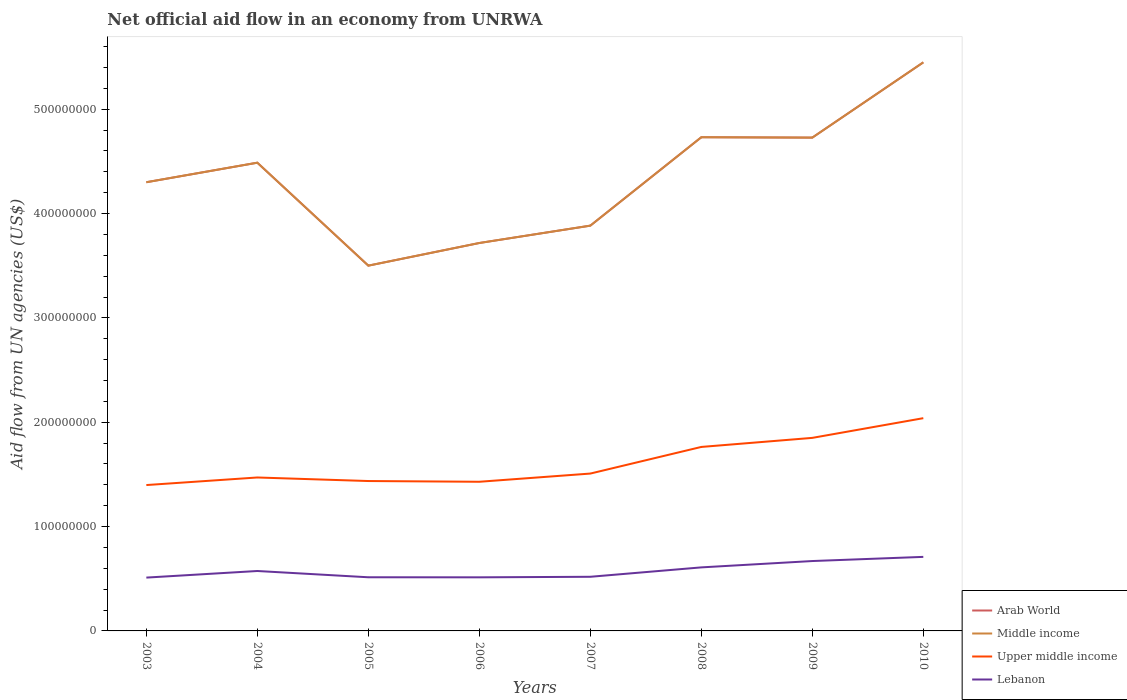How many different coloured lines are there?
Offer a very short reply. 4. Is the number of lines equal to the number of legend labels?
Keep it short and to the point. Yes. Across all years, what is the maximum net official aid flow in Arab World?
Offer a terse response. 3.50e+08. What is the total net official aid flow in Upper middle income in the graph?
Your answer should be very brief. -6.41e+07. What is the difference between the highest and the second highest net official aid flow in Lebanon?
Ensure brevity in your answer.  1.99e+07. What is the difference between the highest and the lowest net official aid flow in Upper middle income?
Offer a terse response. 3. Is the net official aid flow in Lebanon strictly greater than the net official aid flow in Upper middle income over the years?
Ensure brevity in your answer.  Yes. How many lines are there?
Ensure brevity in your answer.  4. How many years are there in the graph?
Offer a terse response. 8. What is the difference between two consecutive major ticks on the Y-axis?
Make the answer very short. 1.00e+08. Are the values on the major ticks of Y-axis written in scientific E-notation?
Your response must be concise. No. How many legend labels are there?
Provide a short and direct response. 4. How are the legend labels stacked?
Your answer should be very brief. Vertical. What is the title of the graph?
Offer a terse response. Net official aid flow in an economy from UNRWA. Does "Sao Tome and Principe" appear as one of the legend labels in the graph?
Your answer should be very brief. No. What is the label or title of the X-axis?
Your answer should be very brief. Years. What is the label or title of the Y-axis?
Ensure brevity in your answer.  Aid flow from UN agencies (US$). What is the Aid flow from UN agencies (US$) in Arab World in 2003?
Keep it short and to the point. 4.30e+08. What is the Aid flow from UN agencies (US$) in Middle income in 2003?
Provide a succinct answer. 4.30e+08. What is the Aid flow from UN agencies (US$) of Upper middle income in 2003?
Keep it short and to the point. 1.40e+08. What is the Aid flow from UN agencies (US$) of Lebanon in 2003?
Give a very brief answer. 5.11e+07. What is the Aid flow from UN agencies (US$) in Arab World in 2004?
Provide a succinct answer. 4.49e+08. What is the Aid flow from UN agencies (US$) of Middle income in 2004?
Offer a very short reply. 4.49e+08. What is the Aid flow from UN agencies (US$) of Upper middle income in 2004?
Your answer should be very brief. 1.47e+08. What is the Aid flow from UN agencies (US$) in Lebanon in 2004?
Offer a very short reply. 5.74e+07. What is the Aid flow from UN agencies (US$) in Arab World in 2005?
Provide a succinct answer. 3.50e+08. What is the Aid flow from UN agencies (US$) of Middle income in 2005?
Provide a short and direct response. 3.50e+08. What is the Aid flow from UN agencies (US$) of Upper middle income in 2005?
Provide a short and direct response. 1.44e+08. What is the Aid flow from UN agencies (US$) in Lebanon in 2005?
Provide a succinct answer. 5.14e+07. What is the Aid flow from UN agencies (US$) in Arab World in 2006?
Offer a very short reply. 3.72e+08. What is the Aid flow from UN agencies (US$) in Middle income in 2006?
Ensure brevity in your answer.  3.72e+08. What is the Aid flow from UN agencies (US$) in Upper middle income in 2006?
Provide a short and direct response. 1.43e+08. What is the Aid flow from UN agencies (US$) in Lebanon in 2006?
Give a very brief answer. 5.14e+07. What is the Aid flow from UN agencies (US$) in Arab World in 2007?
Offer a terse response. 3.88e+08. What is the Aid flow from UN agencies (US$) in Middle income in 2007?
Give a very brief answer. 3.88e+08. What is the Aid flow from UN agencies (US$) in Upper middle income in 2007?
Ensure brevity in your answer.  1.51e+08. What is the Aid flow from UN agencies (US$) in Lebanon in 2007?
Offer a terse response. 5.19e+07. What is the Aid flow from UN agencies (US$) of Arab World in 2008?
Give a very brief answer. 4.73e+08. What is the Aid flow from UN agencies (US$) in Middle income in 2008?
Provide a short and direct response. 4.73e+08. What is the Aid flow from UN agencies (US$) in Upper middle income in 2008?
Provide a short and direct response. 1.76e+08. What is the Aid flow from UN agencies (US$) of Lebanon in 2008?
Ensure brevity in your answer.  6.09e+07. What is the Aid flow from UN agencies (US$) of Arab World in 2009?
Provide a succinct answer. 4.73e+08. What is the Aid flow from UN agencies (US$) in Middle income in 2009?
Offer a very short reply. 4.73e+08. What is the Aid flow from UN agencies (US$) in Upper middle income in 2009?
Provide a short and direct response. 1.85e+08. What is the Aid flow from UN agencies (US$) of Lebanon in 2009?
Offer a terse response. 6.70e+07. What is the Aid flow from UN agencies (US$) in Arab World in 2010?
Offer a terse response. 5.45e+08. What is the Aid flow from UN agencies (US$) in Middle income in 2010?
Keep it short and to the point. 5.45e+08. What is the Aid flow from UN agencies (US$) in Upper middle income in 2010?
Offer a terse response. 2.04e+08. What is the Aid flow from UN agencies (US$) in Lebanon in 2010?
Give a very brief answer. 7.10e+07. Across all years, what is the maximum Aid flow from UN agencies (US$) of Arab World?
Ensure brevity in your answer.  5.45e+08. Across all years, what is the maximum Aid flow from UN agencies (US$) of Middle income?
Offer a very short reply. 5.45e+08. Across all years, what is the maximum Aid flow from UN agencies (US$) of Upper middle income?
Make the answer very short. 2.04e+08. Across all years, what is the maximum Aid flow from UN agencies (US$) of Lebanon?
Give a very brief answer. 7.10e+07. Across all years, what is the minimum Aid flow from UN agencies (US$) in Arab World?
Your answer should be compact. 3.50e+08. Across all years, what is the minimum Aid flow from UN agencies (US$) of Middle income?
Offer a terse response. 3.50e+08. Across all years, what is the minimum Aid flow from UN agencies (US$) of Upper middle income?
Provide a short and direct response. 1.40e+08. Across all years, what is the minimum Aid flow from UN agencies (US$) in Lebanon?
Give a very brief answer. 5.11e+07. What is the total Aid flow from UN agencies (US$) of Arab World in the graph?
Offer a very short reply. 3.48e+09. What is the total Aid flow from UN agencies (US$) in Middle income in the graph?
Offer a terse response. 3.48e+09. What is the total Aid flow from UN agencies (US$) in Upper middle income in the graph?
Your answer should be compact. 1.29e+09. What is the total Aid flow from UN agencies (US$) in Lebanon in the graph?
Your answer should be very brief. 4.62e+08. What is the difference between the Aid flow from UN agencies (US$) in Arab World in 2003 and that in 2004?
Make the answer very short. -1.87e+07. What is the difference between the Aid flow from UN agencies (US$) of Middle income in 2003 and that in 2004?
Offer a terse response. -1.87e+07. What is the difference between the Aid flow from UN agencies (US$) of Upper middle income in 2003 and that in 2004?
Keep it short and to the point. -7.26e+06. What is the difference between the Aid flow from UN agencies (US$) of Lebanon in 2003 and that in 2004?
Make the answer very short. -6.32e+06. What is the difference between the Aid flow from UN agencies (US$) of Arab World in 2003 and that in 2005?
Make the answer very short. 8.00e+07. What is the difference between the Aid flow from UN agencies (US$) in Middle income in 2003 and that in 2005?
Your answer should be very brief. 8.00e+07. What is the difference between the Aid flow from UN agencies (US$) in Upper middle income in 2003 and that in 2005?
Your response must be concise. -3.86e+06. What is the difference between the Aid flow from UN agencies (US$) of Lebanon in 2003 and that in 2005?
Offer a very short reply. -3.10e+05. What is the difference between the Aid flow from UN agencies (US$) in Arab World in 2003 and that in 2006?
Offer a terse response. 5.82e+07. What is the difference between the Aid flow from UN agencies (US$) of Middle income in 2003 and that in 2006?
Provide a succinct answer. 5.82e+07. What is the difference between the Aid flow from UN agencies (US$) of Upper middle income in 2003 and that in 2006?
Your response must be concise. -3.15e+06. What is the difference between the Aid flow from UN agencies (US$) of Lebanon in 2003 and that in 2006?
Your answer should be compact. -2.50e+05. What is the difference between the Aid flow from UN agencies (US$) of Arab World in 2003 and that in 2007?
Give a very brief answer. 4.16e+07. What is the difference between the Aid flow from UN agencies (US$) in Middle income in 2003 and that in 2007?
Your answer should be very brief. 4.16e+07. What is the difference between the Aid flow from UN agencies (US$) in Upper middle income in 2003 and that in 2007?
Your answer should be very brief. -1.10e+07. What is the difference between the Aid flow from UN agencies (US$) of Lebanon in 2003 and that in 2007?
Your response must be concise. -7.80e+05. What is the difference between the Aid flow from UN agencies (US$) of Arab World in 2003 and that in 2008?
Provide a short and direct response. -4.31e+07. What is the difference between the Aid flow from UN agencies (US$) in Middle income in 2003 and that in 2008?
Provide a short and direct response. -4.31e+07. What is the difference between the Aid flow from UN agencies (US$) in Upper middle income in 2003 and that in 2008?
Keep it short and to the point. -3.65e+07. What is the difference between the Aid flow from UN agencies (US$) in Lebanon in 2003 and that in 2008?
Offer a terse response. -9.79e+06. What is the difference between the Aid flow from UN agencies (US$) of Arab World in 2003 and that in 2009?
Offer a very short reply. -4.28e+07. What is the difference between the Aid flow from UN agencies (US$) in Middle income in 2003 and that in 2009?
Provide a short and direct response. -4.28e+07. What is the difference between the Aid flow from UN agencies (US$) in Upper middle income in 2003 and that in 2009?
Offer a very short reply. -4.52e+07. What is the difference between the Aid flow from UN agencies (US$) of Lebanon in 2003 and that in 2009?
Offer a terse response. -1.59e+07. What is the difference between the Aid flow from UN agencies (US$) in Arab World in 2003 and that in 2010?
Keep it short and to the point. -1.15e+08. What is the difference between the Aid flow from UN agencies (US$) of Middle income in 2003 and that in 2010?
Ensure brevity in your answer.  -1.15e+08. What is the difference between the Aid flow from UN agencies (US$) in Upper middle income in 2003 and that in 2010?
Provide a short and direct response. -6.41e+07. What is the difference between the Aid flow from UN agencies (US$) of Lebanon in 2003 and that in 2010?
Your answer should be very brief. -1.99e+07. What is the difference between the Aid flow from UN agencies (US$) in Arab World in 2004 and that in 2005?
Your response must be concise. 9.87e+07. What is the difference between the Aid flow from UN agencies (US$) of Middle income in 2004 and that in 2005?
Your answer should be compact. 9.87e+07. What is the difference between the Aid flow from UN agencies (US$) in Upper middle income in 2004 and that in 2005?
Provide a short and direct response. 3.40e+06. What is the difference between the Aid flow from UN agencies (US$) in Lebanon in 2004 and that in 2005?
Your answer should be very brief. 6.01e+06. What is the difference between the Aid flow from UN agencies (US$) in Arab World in 2004 and that in 2006?
Keep it short and to the point. 7.70e+07. What is the difference between the Aid flow from UN agencies (US$) of Middle income in 2004 and that in 2006?
Offer a terse response. 7.70e+07. What is the difference between the Aid flow from UN agencies (US$) in Upper middle income in 2004 and that in 2006?
Make the answer very short. 4.11e+06. What is the difference between the Aid flow from UN agencies (US$) in Lebanon in 2004 and that in 2006?
Offer a terse response. 6.07e+06. What is the difference between the Aid flow from UN agencies (US$) in Arab World in 2004 and that in 2007?
Provide a succinct answer. 6.03e+07. What is the difference between the Aid flow from UN agencies (US$) in Middle income in 2004 and that in 2007?
Make the answer very short. 6.03e+07. What is the difference between the Aid flow from UN agencies (US$) of Upper middle income in 2004 and that in 2007?
Your answer should be compact. -3.75e+06. What is the difference between the Aid flow from UN agencies (US$) in Lebanon in 2004 and that in 2007?
Your response must be concise. 5.54e+06. What is the difference between the Aid flow from UN agencies (US$) in Arab World in 2004 and that in 2008?
Keep it short and to the point. -2.44e+07. What is the difference between the Aid flow from UN agencies (US$) in Middle income in 2004 and that in 2008?
Give a very brief answer. -2.44e+07. What is the difference between the Aid flow from UN agencies (US$) of Upper middle income in 2004 and that in 2008?
Offer a very short reply. -2.93e+07. What is the difference between the Aid flow from UN agencies (US$) in Lebanon in 2004 and that in 2008?
Ensure brevity in your answer.  -3.47e+06. What is the difference between the Aid flow from UN agencies (US$) of Arab World in 2004 and that in 2009?
Give a very brief answer. -2.40e+07. What is the difference between the Aid flow from UN agencies (US$) of Middle income in 2004 and that in 2009?
Offer a very short reply. -2.40e+07. What is the difference between the Aid flow from UN agencies (US$) in Upper middle income in 2004 and that in 2009?
Your answer should be compact. -3.80e+07. What is the difference between the Aid flow from UN agencies (US$) of Lebanon in 2004 and that in 2009?
Your response must be concise. -9.55e+06. What is the difference between the Aid flow from UN agencies (US$) in Arab World in 2004 and that in 2010?
Provide a succinct answer. -9.62e+07. What is the difference between the Aid flow from UN agencies (US$) in Middle income in 2004 and that in 2010?
Provide a short and direct response. -9.62e+07. What is the difference between the Aid flow from UN agencies (US$) in Upper middle income in 2004 and that in 2010?
Your response must be concise. -5.68e+07. What is the difference between the Aid flow from UN agencies (US$) in Lebanon in 2004 and that in 2010?
Provide a short and direct response. -1.35e+07. What is the difference between the Aid flow from UN agencies (US$) in Arab World in 2005 and that in 2006?
Ensure brevity in your answer.  -2.17e+07. What is the difference between the Aid flow from UN agencies (US$) in Middle income in 2005 and that in 2006?
Your answer should be compact. -2.17e+07. What is the difference between the Aid flow from UN agencies (US$) of Upper middle income in 2005 and that in 2006?
Your response must be concise. 7.10e+05. What is the difference between the Aid flow from UN agencies (US$) of Arab World in 2005 and that in 2007?
Offer a terse response. -3.83e+07. What is the difference between the Aid flow from UN agencies (US$) in Middle income in 2005 and that in 2007?
Give a very brief answer. -3.83e+07. What is the difference between the Aid flow from UN agencies (US$) of Upper middle income in 2005 and that in 2007?
Make the answer very short. -7.15e+06. What is the difference between the Aid flow from UN agencies (US$) of Lebanon in 2005 and that in 2007?
Provide a short and direct response. -4.70e+05. What is the difference between the Aid flow from UN agencies (US$) in Arab World in 2005 and that in 2008?
Offer a terse response. -1.23e+08. What is the difference between the Aid flow from UN agencies (US$) of Middle income in 2005 and that in 2008?
Make the answer very short. -1.23e+08. What is the difference between the Aid flow from UN agencies (US$) of Upper middle income in 2005 and that in 2008?
Ensure brevity in your answer.  -3.27e+07. What is the difference between the Aid flow from UN agencies (US$) of Lebanon in 2005 and that in 2008?
Your response must be concise. -9.48e+06. What is the difference between the Aid flow from UN agencies (US$) of Arab World in 2005 and that in 2009?
Ensure brevity in your answer.  -1.23e+08. What is the difference between the Aid flow from UN agencies (US$) of Middle income in 2005 and that in 2009?
Provide a short and direct response. -1.23e+08. What is the difference between the Aid flow from UN agencies (US$) of Upper middle income in 2005 and that in 2009?
Your answer should be very brief. -4.14e+07. What is the difference between the Aid flow from UN agencies (US$) of Lebanon in 2005 and that in 2009?
Offer a very short reply. -1.56e+07. What is the difference between the Aid flow from UN agencies (US$) of Arab World in 2005 and that in 2010?
Keep it short and to the point. -1.95e+08. What is the difference between the Aid flow from UN agencies (US$) of Middle income in 2005 and that in 2010?
Provide a short and direct response. -1.95e+08. What is the difference between the Aid flow from UN agencies (US$) in Upper middle income in 2005 and that in 2010?
Offer a very short reply. -6.02e+07. What is the difference between the Aid flow from UN agencies (US$) in Lebanon in 2005 and that in 2010?
Give a very brief answer. -1.96e+07. What is the difference between the Aid flow from UN agencies (US$) in Arab World in 2006 and that in 2007?
Your response must be concise. -1.66e+07. What is the difference between the Aid flow from UN agencies (US$) of Middle income in 2006 and that in 2007?
Offer a very short reply. -1.66e+07. What is the difference between the Aid flow from UN agencies (US$) in Upper middle income in 2006 and that in 2007?
Your answer should be compact. -7.86e+06. What is the difference between the Aid flow from UN agencies (US$) in Lebanon in 2006 and that in 2007?
Your answer should be very brief. -5.30e+05. What is the difference between the Aid flow from UN agencies (US$) of Arab World in 2006 and that in 2008?
Keep it short and to the point. -1.01e+08. What is the difference between the Aid flow from UN agencies (US$) of Middle income in 2006 and that in 2008?
Ensure brevity in your answer.  -1.01e+08. What is the difference between the Aid flow from UN agencies (US$) in Upper middle income in 2006 and that in 2008?
Your response must be concise. -3.34e+07. What is the difference between the Aid flow from UN agencies (US$) of Lebanon in 2006 and that in 2008?
Your response must be concise. -9.54e+06. What is the difference between the Aid flow from UN agencies (US$) in Arab World in 2006 and that in 2009?
Your answer should be compact. -1.01e+08. What is the difference between the Aid flow from UN agencies (US$) of Middle income in 2006 and that in 2009?
Your response must be concise. -1.01e+08. What is the difference between the Aid flow from UN agencies (US$) of Upper middle income in 2006 and that in 2009?
Provide a succinct answer. -4.21e+07. What is the difference between the Aid flow from UN agencies (US$) of Lebanon in 2006 and that in 2009?
Make the answer very short. -1.56e+07. What is the difference between the Aid flow from UN agencies (US$) in Arab World in 2006 and that in 2010?
Your answer should be compact. -1.73e+08. What is the difference between the Aid flow from UN agencies (US$) in Middle income in 2006 and that in 2010?
Make the answer very short. -1.73e+08. What is the difference between the Aid flow from UN agencies (US$) of Upper middle income in 2006 and that in 2010?
Provide a succinct answer. -6.10e+07. What is the difference between the Aid flow from UN agencies (US$) in Lebanon in 2006 and that in 2010?
Give a very brief answer. -1.96e+07. What is the difference between the Aid flow from UN agencies (US$) of Arab World in 2007 and that in 2008?
Your answer should be very brief. -8.48e+07. What is the difference between the Aid flow from UN agencies (US$) in Middle income in 2007 and that in 2008?
Ensure brevity in your answer.  -8.48e+07. What is the difference between the Aid flow from UN agencies (US$) in Upper middle income in 2007 and that in 2008?
Your response must be concise. -2.55e+07. What is the difference between the Aid flow from UN agencies (US$) in Lebanon in 2007 and that in 2008?
Provide a short and direct response. -9.01e+06. What is the difference between the Aid flow from UN agencies (US$) of Arab World in 2007 and that in 2009?
Keep it short and to the point. -8.44e+07. What is the difference between the Aid flow from UN agencies (US$) of Middle income in 2007 and that in 2009?
Provide a short and direct response. -8.44e+07. What is the difference between the Aid flow from UN agencies (US$) of Upper middle income in 2007 and that in 2009?
Your answer should be compact. -3.42e+07. What is the difference between the Aid flow from UN agencies (US$) in Lebanon in 2007 and that in 2009?
Your response must be concise. -1.51e+07. What is the difference between the Aid flow from UN agencies (US$) in Arab World in 2007 and that in 2010?
Ensure brevity in your answer.  -1.57e+08. What is the difference between the Aid flow from UN agencies (US$) in Middle income in 2007 and that in 2010?
Provide a succinct answer. -1.57e+08. What is the difference between the Aid flow from UN agencies (US$) in Upper middle income in 2007 and that in 2010?
Your response must be concise. -5.31e+07. What is the difference between the Aid flow from UN agencies (US$) in Lebanon in 2007 and that in 2010?
Your answer should be very brief. -1.91e+07. What is the difference between the Aid flow from UN agencies (US$) in Upper middle income in 2008 and that in 2009?
Make the answer very short. -8.69e+06. What is the difference between the Aid flow from UN agencies (US$) in Lebanon in 2008 and that in 2009?
Offer a terse response. -6.08e+06. What is the difference between the Aid flow from UN agencies (US$) in Arab World in 2008 and that in 2010?
Give a very brief answer. -7.18e+07. What is the difference between the Aid flow from UN agencies (US$) of Middle income in 2008 and that in 2010?
Provide a short and direct response. -7.18e+07. What is the difference between the Aid flow from UN agencies (US$) of Upper middle income in 2008 and that in 2010?
Offer a very short reply. -2.76e+07. What is the difference between the Aid flow from UN agencies (US$) of Lebanon in 2008 and that in 2010?
Offer a terse response. -1.01e+07. What is the difference between the Aid flow from UN agencies (US$) in Arab World in 2009 and that in 2010?
Your answer should be compact. -7.21e+07. What is the difference between the Aid flow from UN agencies (US$) of Middle income in 2009 and that in 2010?
Ensure brevity in your answer.  -7.21e+07. What is the difference between the Aid flow from UN agencies (US$) of Upper middle income in 2009 and that in 2010?
Make the answer very short. -1.89e+07. What is the difference between the Aid flow from UN agencies (US$) in Lebanon in 2009 and that in 2010?
Your response must be concise. -3.99e+06. What is the difference between the Aid flow from UN agencies (US$) of Arab World in 2003 and the Aid flow from UN agencies (US$) of Middle income in 2004?
Offer a terse response. -1.87e+07. What is the difference between the Aid flow from UN agencies (US$) in Arab World in 2003 and the Aid flow from UN agencies (US$) in Upper middle income in 2004?
Offer a terse response. 2.83e+08. What is the difference between the Aid flow from UN agencies (US$) of Arab World in 2003 and the Aid flow from UN agencies (US$) of Lebanon in 2004?
Your answer should be very brief. 3.73e+08. What is the difference between the Aid flow from UN agencies (US$) in Middle income in 2003 and the Aid flow from UN agencies (US$) in Upper middle income in 2004?
Your answer should be compact. 2.83e+08. What is the difference between the Aid flow from UN agencies (US$) of Middle income in 2003 and the Aid flow from UN agencies (US$) of Lebanon in 2004?
Ensure brevity in your answer.  3.73e+08. What is the difference between the Aid flow from UN agencies (US$) of Upper middle income in 2003 and the Aid flow from UN agencies (US$) of Lebanon in 2004?
Make the answer very short. 8.24e+07. What is the difference between the Aid flow from UN agencies (US$) in Arab World in 2003 and the Aid flow from UN agencies (US$) in Middle income in 2005?
Your answer should be compact. 8.00e+07. What is the difference between the Aid flow from UN agencies (US$) in Arab World in 2003 and the Aid flow from UN agencies (US$) in Upper middle income in 2005?
Your response must be concise. 2.86e+08. What is the difference between the Aid flow from UN agencies (US$) in Arab World in 2003 and the Aid flow from UN agencies (US$) in Lebanon in 2005?
Offer a terse response. 3.79e+08. What is the difference between the Aid flow from UN agencies (US$) in Middle income in 2003 and the Aid flow from UN agencies (US$) in Upper middle income in 2005?
Offer a terse response. 2.86e+08. What is the difference between the Aid flow from UN agencies (US$) of Middle income in 2003 and the Aid flow from UN agencies (US$) of Lebanon in 2005?
Provide a short and direct response. 3.79e+08. What is the difference between the Aid flow from UN agencies (US$) of Upper middle income in 2003 and the Aid flow from UN agencies (US$) of Lebanon in 2005?
Your answer should be very brief. 8.84e+07. What is the difference between the Aid flow from UN agencies (US$) of Arab World in 2003 and the Aid flow from UN agencies (US$) of Middle income in 2006?
Offer a terse response. 5.82e+07. What is the difference between the Aid flow from UN agencies (US$) of Arab World in 2003 and the Aid flow from UN agencies (US$) of Upper middle income in 2006?
Your answer should be very brief. 2.87e+08. What is the difference between the Aid flow from UN agencies (US$) in Arab World in 2003 and the Aid flow from UN agencies (US$) in Lebanon in 2006?
Your answer should be very brief. 3.79e+08. What is the difference between the Aid flow from UN agencies (US$) in Middle income in 2003 and the Aid flow from UN agencies (US$) in Upper middle income in 2006?
Keep it short and to the point. 2.87e+08. What is the difference between the Aid flow from UN agencies (US$) in Middle income in 2003 and the Aid flow from UN agencies (US$) in Lebanon in 2006?
Your answer should be compact. 3.79e+08. What is the difference between the Aid flow from UN agencies (US$) in Upper middle income in 2003 and the Aid flow from UN agencies (US$) in Lebanon in 2006?
Your answer should be compact. 8.84e+07. What is the difference between the Aid flow from UN agencies (US$) in Arab World in 2003 and the Aid flow from UN agencies (US$) in Middle income in 2007?
Provide a short and direct response. 4.16e+07. What is the difference between the Aid flow from UN agencies (US$) of Arab World in 2003 and the Aid flow from UN agencies (US$) of Upper middle income in 2007?
Give a very brief answer. 2.79e+08. What is the difference between the Aid flow from UN agencies (US$) in Arab World in 2003 and the Aid flow from UN agencies (US$) in Lebanon in 2007?
Provide a succinct answer. 3.78e+08. What is the difference between the Aid flow from UN agencies (US$) in Middle income in 2003 and the Aid flow from UN agencies (US$) in Upper middle income in 2007?
Offer a terse response. 2.79e+08. What is the difference between the Aid flow from UN agencies (US$) in Middle income in 2003 and the Aid flow from UN agencies (US$) in Lebanon in 2007?
Offer a terse response. 3.78e+08. What is the difference between the Aid flow from UN agencies (US$) of Upper middle income in 2003 and the Aid flow from UN agencies (US$) of Lebanon in 2007?
Your response must be concise. 8.79e+07. What is the difference between the Aid flow from UN agencies (US$) in Arab World in 2003 and the Aid flow from UN agencies (US$) in Middle income in 2008?
Offer a very short reply. -4.31e+07. What is the difference between the Aid flow from UN agencies (US$) in Arab World in 2003 and the Aid flow from UN agencies (US$) in Upper middle income in 2008?
Give a very brief answer. 2.54e+08. What is the difference between the Aid flow from UN agencies (US$) of Arab World in 2003 and the Aid flow from UN agencies (US$) of Lebanon in 2008?
Ensure brevity in your answer.  3.69e+08. What is the difference between the Aid flow from UN agencies (US$) of Middle income in 2003 and the Aid flow from UN agencies (US$) of Upper middle income in 2008?
Your response must be concise. 2.54e+08. What is the difference between the Aid flow from UN agencies (US$) in Middle income in 2003 and the Aid flow from UN agencies (US$) in Lebanon in 2008?
Provide a short and direct response. 3.69e+08. What is the difference between the Aid flow from UN agencies (US$) of Upper middle income in 2003 and the Aid flow from UN agencies (US$) of Lebanon in 2008?
Your answer should be very brief. 7.89e+07. What is the difference between the Aid flow from UN agencies (US$) of Arab World in 2003 and the Aid flow from UN agencies (US$) of Middle income in 2009?
Your answer should be very brief. -4.28e+07. What is the difference between the Aid flow from UN agencies (US$) in Arab World in 2003 and the Aid flow from UN agencies (US$) in Upper middle income in 2009?
Provide a short and direct response. 2.45e+08. What is the difference between the Aid flow from UN agencies (US$) of Arab World in 2003 and the Aid flow from UN agencies (US$) of Lebanon in 2009?
Your response must be concise. 3.63e+08. What is the difference between the Aid flow from UN agencies (US$) in Middle income in 2003 and the Aid flow from UN agencies (US$) in Upper middle income in 2009?
Offer a very short reply. 2.45e+08. What is the difference between the Aid flow from UN agencies (US$) in Middle income in 2003 and the Aid flow from UN agencies (US$) in Lebanon in 2009?
Make the answer very short. 3.63e+08. What is the difference between the Aid flow from UN agencies (US$) of Upper middle income in 2003 and the Aid flow from UN agencies (US$) of Lebanon in 2009?
Provide a succinct answer. 7.28e+07. What is the difference between the Aid flow from UN agencies (US$) in Arab World in 2003 and the Aid flow from UN agencies (US$) in Middle income in 2010?
Your answer should be compact. -1.15e+08. What is the difference between the Aid flow from UN agencies (US$) in Arab World in 2003 and the Aid flow from UN agencies (US$) in Upper middle income in 2010?
Give a very brief answer. 2.26e+08. What is the difference between the Aid flow from UN agencies (US$) in Arab World in 2003 and the Aid flow from UN agencies (US$) in Lebanon in 2010?
Provide a succinct answer. 3.59e+08. What is the difference between the Aid flow from UN agencies (US$) in Middle income in 2003 and the Aid flow from UN agencies (US$) in Upper middle income in 2010?
Your answer should be compact. 2.26e+08. What is the difference between the Aid flow from UN agencies (US$) in Middle income in 2003 and the Aid flow from UN agencies (US$) in Lebanon in 2010?
Provide a short and direct response. 3.59e+08. What is the difference between the Aid flow from UN agencies (US$) of Upper middle income in 2003 and the Aid flow from UN agencies (US$) of Lebanon in 2010?
Your answer should be compact. 6.88e+07. What is the difference between the Aid flow from UN agencies (US$) of Arab World in 2004 and the Aid flow from UN agencies (US$) of Middle income in 2005?
Offer a terse response. 9.87e+07. What is the difference between the Aid flow from UN agencies (US$) of Arab World in 2004 and the Aid flow from UN agencies (US$) of Upper middle income in 2005?
Offer a very short reply. 3.05e+08. What is the difference between the Aid flow from UN agencies (US$) in Arab World in 2004 and the Aid flow from UN agencies (US$) in Lebanon in 2005?
Keep it short and to the point. 3.97e+08. What is the difference between the Aid flow from UN agencies (US$) in Middle income in 2004 and the Aid flow from UN agencies (US$) in Upper middle income in 2005?
Provide a short and direct response. 3.05e+08. What is the difference between the Aid flow from UN agencies (US$) in Middle income in 2004 and the Aid flow from UN agencies (US$) in Lebanon in 2005?
Ensure brevity in your answer.  3.97e+08. What is the difference between the Aid flow from UN agencies (US$) in Upper middle income in 2004 and the Aid flow from UN agencies (US$) in Lebanon in 2005?
Make the answer very short. 9.56e+07. What is the difference between the Aid flow from UN agencies (US$) in Arab World in 2004 and the Aid flow from UN agencies (US$) in Middle income in 2006?
Offer a very short reply. 7.70e+07. What is the difference between the Aid flow from UN agencies (US$) in Arab World in 2004 and the Aid flow from UN agencies (US$) in Upper middle income in 2006?
Offer a terse response. 3.06e+08. What is the difference between the Aid flow from UN agencies (US$) in Arab World in 2004 and the Aid flow from UN agencies (US$) in Lebanon in 2006?
Your answer should be very brief. 3.97e+08. What is the difference between the Aid flow from UN agencies (US$) in Middle income in 2004 and the Aid flow from UN agencies (US$) in Upper middle income in 2006?
Offer a very short reply. 3.06e+08. What is the difference between the Aid flow from UN agencies (US$) in Middle income in 2004 and the Aid flow from UN agencies (US$) in Lebanon in 2006?
Make the answer very short. 3.97e+08. What is the difference between the Aid flow from UN agencies (US$) of Upper middle income in 2004 and the Aid flow from UN agencies (US$) of Lebanon in 2006?
Offer a very short reply. 9.57e+07. What is the difference between the Aid flow from UN agencies (US$) in Arab World in 2004 and the Aid flow from UN agencies (US$) in Middle income in 2007?
Your response must be concise. 6.03e+07. What is the difference between the Aid flow from UN agencies (US$) in Arab World in 2004 and the Aid flow from UN agencies (US$) in Upper middle income in 2007?
Your answer should be very brief. 2.98e+08. What is the difference between the Aid flow from UN agencies (US$) of Arab World in 2004 and the Aid flow from UN agencies (US$) of Lebanon in 2007?
Offer a terse response. 3.97e+08. What is the difference between the Aid flow from UN agencies (US$) in Middle income in 2004 and the Aid flow from UN agencies (US$) in Upper middle income in 2007?
Your response must be concise. 2.98e+08. What is the difference between the Aid flow from UN agencies (US$) in Middle income in 2004 and the Aid flow from UN agencies (US$) in Lebanon in 2007?
Your response must be concise. 3.97e+08. What is the difference between the Aid flow from UN agencies (US$) in Upper middle income in 2004 and the Aid flow from UN agencies (US$) in Lebanon in 2007?
Ensure brevity in your answer.  9.52e+07. What is the difference between the Aid flow from UN agencies (US$) of Arab World in 2004 and the Aid flow from UN agencies (US$) of Middle income in 2008?
Offer a terse response. -2.44e+07. What is the difference between the Aid flow from UN agencies (US$) of Arab World in 2004 and the Aid flow from UN agencies (US$) of Upper middle income in 2008?
Your response must be concise. 2.72e+08. What is the difference between the Aid flow from UN agencies (US$) of Arab World in 2004 and the Aid flow from UN agencies (US$) of Lebanon in 2008?
Your answer should be compact. 3.88e+08. What is the difference between the Aid flow from UN agencies (US$) of Middle income in 2004 and the Aid flow from UN agencies (US$) of Upper middle income in 2008?
Make the answer very short. 2.72e+08. What is the difference between the Aid flow from UN agencies (US$) of Middle income in 2004 and the Aid flow from UN agencies (US$) of Lebanon in 2008?
Your answer should be compact. 3.88e+08. What is the difference between the Aid flow from UN agencies (US$) of Upper middle income in 2004 and the Aid flow from UN agencies (US$) of Lebanon in 2008?
Offer a very short reply. 8.62e+07. What is the difference between the Aid flow from UN agencies (US$) of Arab World in 2004 and the Aid flow from UN agencies (US$) of Middle income in 2009?
Your answer should be very brief. -2.40e+07. What is the difference between the Aid flow from UN agencies (US$) of Arab World in 2004 and the Aid flow from UN agencies (US$) of Upper middle income in 2009?
Offer a terse response. 2.64e+08. What is the difference between the Aid flow from UN agencies (US$) in Arab World in 2004 and the Aid flow from UN agencies (US$) in Lebanon in 2009?
Give a very brief answer. 3.82e+08. What is the difference between the Aid flow from UN agencies (US$) of Middle income in 2004 and the Aid flow from UN agencies (US$) of Upper middle income in 2009?
Your answer should be very brief. 2.64e+08. What is the difference between the Aid flow from UN agencies (US$) in Middle income in 2004 and the Aid flow from UN agencies (US$) in Lebanon in 2009?
Keep it short and to the point. 3.82e+08. What is the difference between the Aid flow from UN agencies (US$) in Upper middle income in 2004 and the Aid flow from UN agencies (US$) in Lebanon in 2009?
Your answer should be compact. 8.01e+07. What is the difference between the Aid flow from UN agencies (US$) of Arab World in 2004 and the Aid flow from UN agencies (US$) of Middle income in 2010?
Provide a succinct answer. -9.62e+07. What is the difference between the Aid flow from UN agencies (US$) in Arab World in 2004 and the Aid flow from UN agencies (US$) in Upper middle income in 2010?
Give a very brief answer. 2.45e+08. What is the difference between the Aid flow from UN agencies (US$) in Arab World in 2004 and the Aid flow from UN agencies (US$) in Lebanon in 2010?
Your response must be concise. 3.78e+08. What is the difference between the Aid flow from UN agencies (US$) of Middle income in 2004 and the Aid flow from UN agencies (US$) of Upper middle income in 2010?
Offer a terse response. 2.45e+08. What is the difference between the Aid flow from UN agencies (US$) of Middle income in 2004 and the Aid flow from UN agencies (US$) of Lebanon in 2010?
Ensure brevity in your answer.  3.78e+08. What is the difference between the Aid flow from UN agencies (US$) of Upper middle income in 2004 and the Aid flow from UN agencies (US$) of Lebanon in 2010?
Your response must be concise. 7.61e+07. What is the difference between the Aid flow from UN agencies (US$) in Arab World in 2005 and the Aid flow from UN agencies (US$) in Middle income in 2006?
Your response must be concise. -2.17e+07. What is the difference between the Aid flow from UN agencies (US$) in Arab World in 2005 and the Aid flow from UN agencies (US$) in Upper middle income in 2006?
Keep it short and to the point. 2.07e+08. What is the difference between the Aid flow from UN agencies (US$) in Arab World in 2005 and the Aid flow from UN agencies (US$) in Lebanon in 2006?
Ensure brevity in your answer.  2.99e+08. What is the difference between the Aid flow from UN agencies (US$) of Middle income in 2005 and the Aid flow from UN agencies (US$) of Upper middle income in 2006?
Make the answer very short. 2.07e+08. What is the difference between the Aid flow from UN agencies (US$) of Middle income in 2005 and the Aid flow from UN agencies (US$) of Lebanon in 2006?
Give a very brief answer. 2.99e+08. What is the difference between the Aid flow from UN agencies (US$) of Upper middle income in 2005 and the Aid flow from UN agencies (US$) of Lebanon in 2006?
Your answer should be compact. 9.23e+07. What is the difference between the Aid flow from UN agencies (US$) of Arab World in 2005 and the Aid flow from UN agencies (US$) of Middle income in 2007?
Offer a terse response. -3.83e+07. What is the difference between the Aid flow from UN agencies (US$) in Arab World in 2005 and the Aid flow from UN agencies (US$) in Upper middle income in 2007?
Offer a terse response. 1.99e+08. What is the difference between the Aid flow from UN agencies (US$) of Arab World in 2005 and the Aid flow from UN agencies (US$) of Lebanon in 2007?
Your answer should be compact. 2.98e+08. What is the difference between the Aid flow from UN agencies (US$) of Middle income in 2005 and the Aid flow from UN agencies (US$) of Upper middle income in 2007?
Offer a very short reply. 1.99e+08. What is the difference between the Aid flow from UN agencies (US$) of Middle income in 2005 and the Aid flow from UN agencies (US$) of Lebanon in 2007?
Offer a very short reply. 2.98e+08. What is the difference between the Aid flow from UN agencies (US$) in Upper middle income in 2005 and the Aid flow from UN agencies (US$) in Lebanon in 2007?
Offer a very short reply. 9.18e+07. What is the difference between the Aid flow from UN agencies (US$) in Arab World in 2005 and the Aid flow from UN agencies (US$) in Middle income in 2008?
Offer a very short reply. -1.23e+08. What is the difference between the Aid flow from UN agencies (US$) in Arab World in 2005 and the Aid flow from UN agencies (US$) in Upper middle income in 2008?
Your answer should be compact. 1.74e+08. What is the difference between the Aid flow from UN agencies (US$) in Arab World in 2005 and the Aid flow from UN agencies (US$) in Lebanon in 2008?
Offer a terse response. 2.89e+08. What is the difference between the Aid flow from UN agencies (US$) in Middle income in 2005 and the Aid flow from UN agencies (US$) in Upper middle income in 2008?
Offer a very short reply. 1.74e+08. What is the difference between the Aid flow from UN agencies (US$) of Middle income in 2005 and the Aid flow from UN agencies (US$) of Lebanon in 2008?
Offer a terse response. 2.89e+08. What is the difference between the Aid flow from UN agencies (US$) in Upper middle income in 2005 and the Aid flow from UN agencies (US$) in Lebanon in 2008?
Ensure brevity in your answer.  8.28e+07. What is the difference between the Aid flow from UN agencies (US$) in Arab World in 2005 and the Aid flow from UN agencies (US$) in Middle income in 2009?
Ensure brevity in your answer.  -1.23e+08. What is the difference between the Aid flow from UN agencies (US$) in Arab World in 2005 and the Aid flow from UN agencies (US$) in Upper middle income in 2009?
Give a very brief answer. 1.65e+08. What is the difference between the Aid flow from UN agencies (US$) in Arab World in 2005 and the Aid flow from UN agencies (US$) in Lebanon in 2009?
Provide a short and direct response. 2.83e+08. What is the difference between the Aid flow from UN agencies (US$) in Middle income in 2005 and the Aid flow from UN agencies (US$) in Upper middle income in 2009?
Keep it short and to the point. 1.65e+08. What is the difference between the Aid flow from UN agencies (US$) in Middle income in 2005 and the Aid flow from UN agencies (US$) in Lebanon in 2009?
Your answer should be very brief. 2.83e+08. What is the difference between the Aid flow from UN agencies (US$) in Upper middle income in 2005 and the Aid flow from UN agencies (US$) in Lebanon in 2009?
Provide a succinct answer. 7.67e+07. What is the difference between the Aid flow from UN agencies (US$) of Arab World in 2005 and the Aid flow from UN agencies (US$) of Middle income in 2010?
Your answer should be compact. -1.95e+08. What is the difference between the Aid flow from UN agencies (US$) in Arab World in 2005 and the Aid flow from UN agencies (US$) in Upper middle income in 2010?
Offer a terse response. 1.46e+08. What is the difference between the Aid flow from UN agencies (US$) of Arab World in 2005 and the Aid flow from UN agencies (US$) of Lebanon in 2010?
Offer a terse response. 2.79e+08. What is the difference between the Aid flow from UN agencies (US$) in Middle income in 2005 and the Aid flow from UN agencies (US$) in Upper middle income in 2010?
Your answer should be very brief. 1.46e+08. What is the difference between the Aid flow from UN agencies (US$) of Middle income in 2005 and the Aid flow from UN agencies (US$) of Lebanon in 2010?
Offer a very short reply. 2.79e+08. What is the difference between the Aid flow from UN agencies (US$) in Upper middle income in 2005 and the Aid flow from UN agencies (US$) in Lebanon in 2010?
Give a very brief answer. 7.27e+07. What is the difference between the Aid flow from UN agencies (US$) of Arab World in 2006 and the Aid flow from UN agencies (US$) of Middle income in 2007?
Provide a short and direct response. -1.66e+07. What is the difference between the Aid flow from UN agencies (US$) in Arab World in 2006 and the Aid flow from UN agencies (US$) in Upper middle income in 2007?
Keep it short and to the point. 2.21e+08. What is the difference between the Aid flow from UN agencies (US$) of Arab World in 2006 and the Aid flow from UN agencies (US$) of Lebanon in 2007?
Provide a succinct answer. 3.20e+08. What is the difference between the Aid flow from UN agencies (US$) in Middle income in 2006 and the Aid flow from UN agencies (US$) in Upper middle income in 2007?
Offer a very short reply. 2.21e+08. What is the difference between the Aid flow from UN agencies (US$) of Middle income in 2006 and the Aid flow from UN agencies (US$) of Lebanon in 2007?
Make the answer very short. 3.20e+08. What is the difference between the Aid flow from UN agencies (US$) of Upper middle income in 2006 and the Aid flow from UN agencies (US$) of Lebanon in 2007?
Provide a short and direct response. 9.11e+07. What is the difference between the Aid flow from UN agencies (US$) of Arab World in 2006 and the Aid flow from UN agencies (US$) of Middle income in 2008?
Ensure brevity in your answer.  -1.01e+08. What is the difference between the Aid flow from UN agencies (US$) of Arab World in 2006 and the Aid flow from UN agencies (US$) of Upper middle income in 2008?
Your answer should be compact. 1.95e+08. What is the difference between the Aid flow from UN agencies (US$) in Arab World in 2006 and the Aid flow from UN agencies (US$) in Lebanon in 2008?
Your response must be concise. 3.11e+08. What is the difference between the Aid flow from UN agencies (US$) of Middle income in 2006 and the Aid flow from UN agencies (US$) of Upper middle income in 2008?
Your answer should be compact. 1.95e+08. What is the difference between the Aid flow from UN agencies (US$) of Middle income in 2006 and the Aid flow from UN agencies (US$) of Lebanon in 2008?
Your answer should be compact. 3.11e+08. What is the difference between the Aid flow from UN agencies (US$) in Upper middle income in 2006 and the Aid flow from UN agencies (US$) in Lebanon in 2008?
Offer a very short reply. 8.21e+07. What is the difference between the Aid flow from UN agencies (US$) in Arab World in 2006 and the Aid flow from UN agencies (US$) in Middle income in 2009?
Your response must be concise. -1.01e+08. What is the difference between the Aid flow from UN agencies (US$) of Arab World in 2006 and the Aid flow from UN agencies (US$) of Upper middle income in 2009?
Offer a very short reply. 1.87e+08. What is the difference between the Aid flow from UN agencies (US$) of Arab World in 2006 and the Aid flow from UN agencies (US$) of Lebanon in 2009?
Your answer should be very brief. 3.05e+08. What is the difference between the Aid flow from UN agencies (US$) of Middle income in 2006 and the Aid flow from UN agencies (US$) of Upper middle income in 2009?
Your answer should be very brief. 1.87e+08. What is the difference between the Aid flow from UN agencies (US$) of Middle income in 2006 and the Aid flow from UN agencies (US$) of Lebanon in 2009?
Ensure brevity in your answer.  3.05e+08. What is the difference between the Aid flow from UN agencies (US$) in Upper middle income in 2006 and the Aid flow from UN agencies (US$) in Lebanon in 2009?
Your answer should be very brief. 7.60e+07. What is the difference between the Aid flow from UN agencies (US$) of Arab World in 2006 and the Aid flow from UN agencies (US$) of Middle income in 2010?
Offer a very short reply. -1.73e+08. What is the difference between the Aid flow from UN agencies (US$) in Arab World in 2006 and the Aid flow from UN agencies (US$) in Upper middle income in 2010?
Keep it short and to the point. 1.68e+08. What is the difference between the Aid flow from UN agencies (US$) of Arab World in 2006 and the Aid flow from UN agencies (US$) of Lebanon in 2010?
Keep it short and to the point. 3.01e+08. What is the difference between the Aid flow from UN agencies (US$) of Middle income in 2006 and the Aid flow from UN agencies (US$) of Upper middle income in 2010?
Make the answer very short. 1.68e+08. What is the difference between the Aid flow from UN agencies (US$) in Middle income in 2006 and the Aid flow from UN agencies (US$) in Lebanon in 2010?
Give a very brief answer. 3.01e+08. What is the difference between the Aid flow from UN agencies (US$) in Upper middle income in 2006 and the Aid flow from UN agencies (US$) in Lebanon in 2010?
Make the answer very short. 7.20e+07. What is the difference between the Aid flow from UN agencies (US$) in Arab World in 2007 and the Aid flow from UN agencies (US$) in Middle income in 2008?
Your answer should be very brief. -8.48e+07. What is the difference between the Aid flow from UN agencies (US$) in Arab World in 2007 and the Aid flow from UN agencies (US$) in Upper middle income in 2008?
Your response must be concise. 2.12e+08. What is the difference between the Aid flow from UN agencies (US$) of Arab World in 2007 and the Aid flow from UN agencies (US$) of Lebanon in 2008?
Give a very brief answer. 3.28e+08. What is the difference between the Aid flow from UN agencies (US$) of Middle income in 2007 and the Aid flow from UN agencies (US$) of Upper middle income in 2008?
Provide a short and direct response. 2.12e+08. What is the difference between the Aid flow from UN agencies (US$) of Middle income in 2007 and the Aid flow from UN agencies (US$) of Lebanon in 2008?
Keep it short and to the point. 3.28e+08. What is the difference between the Aid flow from UN agencies (US$) of Upper middle income in 2007 and the Aid flow from UN agencies (US$) of Lebanon in 2008?
Make the answer very short. 8.99e+07. What is the difference between the Aid flow from UN agencies (US$) in Arab World in 2007 and the Aid flow from UN agencies (US$) in Middle income in 2009?
Keep it short and to the point. -8.44e+07. What is the difference between the Aid flow from UN agencies (US$) of Arab World in 2007 and the Aid flow from UN agencies (US$) of Upper middle income in 2009?
Offer a terse response. 2.03e+08. What is the difference between the Aid flow from UN agencies (US$) of Arab World in 2007 and the Aid flow from UN agencies (US$) of Lebanon in 2009?
Give a very brief answer. 3.21e+08. What is the difference between the Aid flow from UN agencies (US$) of Middle income in 2007 and the Aid flow from UN agencies (US$) of Upper middle income in 2009?
Make the answer very short. 2.03e+08. What is the difference between the Aid flow from UN agencies (US$) in Middle income in 2007 and the Aid flow from UN agencies (US$) in Lebanon in 2009?
Offer a terse response. 3.21e+08. What is the difference between the Aid flow from UN agencies (US$) in Upper middle income in 2007 and the Aid flow from UN agencies (US$) in Lebanon in 2009?
Ensure brevity in your answer.  8.38e+07. What is the difference between the Aid flow from UN agencies (US$) in Arab World in 2007 and the Aid flow from UN agencies (US$) in Middle income in 2010?
Your response must be concise. -1.57e+08. What is the difference between the Aid flow from UN agencies (US$) in Arab World in 2007 and the Aid flow from UN agencies (US$) in Upper middle income in 2010?
Ensure brevity in your answer.  1.85e+08. What is the difference between the Aid flow from UN agencies (US$) in Arab World in 2007 and the Aid flow from UN agencies (US$) in Lebanon in 2010?
Ensure brevity in your answer.  3.17e+08. What is the difference between the Aid flow from UN agencies (US$) of Middle income in 2007 and the Aid flow from UN agencies (US$) of Upper middle income in 2010?
Your answer should be compact. 1.85e+08. What is the difference between the Aid flow from UN agencies (US$) of Middle income in 2007 and the Aid flow from UN agencies (US$) of Lebanon in 2010?
Ensure brevity in your answer.  3.17e+08. What is the difference between the Aid flow from UN agencies (US$) in Upper middle income in 2007 and the Aid flow from UN agencies (US$) in Lebanon in 2010?
Your answer should be very brief. 7.98e+07. What is the difference between the Aid flow from UN agencies (US$) in Arab World in 2008 and the Aid flow from UN agencies (US$) in Upper middle income in 2009?
Keep it short and to the point. 2.88e+08. What is the difference between the Aid flow from UN agencies (US$) of Arab World in 2008 and the Aid flow from UN agencies (US$) of Lebanon in 2009?
Make the answer very short. 4.06e+08. What is the difference between the Aid flow from UN agencies (US$) in Middle income in 2008 and the Aid flow from UN agencies (US$) in Upper middle income in 2009?
Keep it short and to the point. 2.88e+08. What is the difference between the Aid flow from UN agencies (US$) of Middle income in 2008 and the Aid flow from UN agencies (US$) of Lebanon in 2009?
Keep it short and to the point. 4.06e+08. What is the difference between the Aid flow from UN agencies (US$) of Upper middle income in 2008 and the Aid flow from UN agencies (US$) of Lebanon in 2009?
Your answer should be compact. 1.09e+08. What is the difference between the Aid flow from UN agencies (US$) in Arab World in 2008 and the Aid flow from UN agencies (US$) in Middle income in 2010?
Provide a short and direct response. -7.18e+07. What is the difference between the Aid flow from UN agencies (US$) of Arab World in 2008 and the Aid flow from UN agencies (US$) of Upper middle income in 2010?
Give a very brief answer. 2.69e+08. What is the difference between the Aid flow from UN agencies (US$) in Arab World in 2008 and the Aid flow from UN agencies (US$) in Lebanon in 2010?
Offer a very short reply. 4.02e+08. What is the difference between the Aid flow from UN agencies (US$) of Middle income in 2008 and the Aid flow from UN agencies (US$) of Upper middle income in 2010?
Offer a terse response. 2.69e+08. What is the difference between the Aid flow from UN agencies (US$) in Middle income in 2008 and the Aid flow from UN agencies (US$) in Lebanon in 2010?
Your response must be concise. 4.02e+08. What is the difference between the Aid flow from UN agencies (US$) in Upper middle income in 2008 and the Aid flow from UN agencies (US$) in Lebanon in 2010?
Give a very brief answer. 1.05e+08. What is the difference between the Aid flow from UN agencies (US$) in Arab World in 2009 and the Aid flow from UN agencies (US$) in Middle income in 2010?
Your response must be concise. -7.21e+07. What is the difference between the Aid flow from UN agencies (US$) in Arab World in 2009 and the Aid flow from UN agencies (US$) in Upper middle income in 2010?
Make the answer very short. 2.69e+08. What is the difference between the Aid flow from UN agencies (US$) of Arab World in 2009 and the Aid flow from UN agencies (US$) of Lebanon in 2010?
Give a very brief answer. 4.02e+08. What is the difference between the Aid flow from UN agencies (US$) of Middle income in 2009 and the Aid flow from UN agencies (US$) of Upper middle income in 2010?
Make the answer very short. 2.69e+08. What is the difference between the Aid flow from UN agencies (US$) of Middle income in 2009 and the Aid flow from UN agencies (US$) of Lebanon in 2010?
Offer a very short reply. 4.02e+08. What is the difference between the Aid flow from UN agencies (US$) of Upper middle income in 2009 and the Aid flow from UN agencies (US$) of Lebanon in 2010?
Provide a short and direct response. 1.14e+08. What is the average Aid flow from UN agencies (US$) of Arab World per year?
Provide a short and direct response. 4.35e+08. What is the average Aid flow from UN agencies (US$) of Middle income per year?
Make the answer very short. 4.35e+08. What is the average Aid flow from UN agencies (US$) in Upper middle income per year?
Keep it short and to the point. 1.61e+08. What is the average Aid flow from UN agencies (US$) in Lebanon per year?
Ensure brevity in your answer.  5.78e+07. In the year 2003, what is the difference between the Aid flow from UN agencies (US$) in Arab World and Aid flow from UN agencies (US$) in Middle income?
Your answer should be compact. 0. In the year 2003, what is the difference between the Aid flow from UN agencies (US$) of Arab World and Aid flow from UN agencies (US$) of Upper middle income?
Offer a terse response. 2.90e+08. In the year 2003, what is the difference between the Aid flow from UN agencies (US$) of Arab World and Aid flow from UN agencies (US$) of Lebanon?
Your answer should be compact. 3.79e+08. In the year 2003, what is the difference between the Aid flow from UN agencies (US$) in Middle income and Aid flow from UN agencies (US$) in Upper middle income?
Offer a terse response. 2.90e+08. In the year 2003, what is the difference between the Aid flow from UN agencies (US$) in Middle income and Aid flow from UN agencies (US$) in Lebanon?
Offer a terse response. 3.79e+08. In the year 2003, what is the difference between the Aid flow from UN agencies (US$) of Upper middle income and Aid flow from UN agencies (US$) of Lebanon?
Ensure brevity in your answer.  8.87e+07. In the year 2004, what is the difference between the Aid flow from UN agencies (US$) in Arab World and Aid flow from UN agencies (US$) in Upper middle income?
Give a very brief answer. 3.02e+08. In the year 2004, what is the difference between the Aid flow from UN agencies (US$) in Arab World and Aid flow from UN agencies (US$) in Lebanon?
Your answer should be compact. 3.91e+08. In the year 2004, what is the difference between the Aid flow from UN agencies (US$) of Middle income and Aid flow from UN agencies (US$) of Upper middle income?
Your answer should be compact. 3.02e+08. In the year 2004, what is the difference between the Aid flow from UN agencies (US$) in Middle income and Aid flow from UN agencies (US$) in Lebanon?
Your response must be concise. 3.91e+08. In the year 2004, what is the difference between the Aid flow from UN agencies (US$) of Upper middle income and Aid flow from UN agencies (US$) of Lebanon?
Provide a succinct answer. 8.96e+07. In the year 2005, what is the difference between the Aid flow from UN agencies (US$) in Arab World and Aid flow from UN agencies (US$) in Upper middle income?
Your answer should be compact. 2.06e+08. In the year 2005, what is the difference between the Aid flow from UN agencies (US$) of Arab World and Aid flow from UN agencies (US$) of Lebanon?
Provide a short and direct response. 2.99e+08. In the year 2005, what is the difference between the Aid flow from UN agencies (US$) of Middle income and Aid flow from UN agencies (US$) of Upper middle income?
Your answer should be very brief. 2.06e+08. In the year 2005, what is the difference between the Aid flow from UN agencies (US$) of Middle income and Aid flow from UN agencies (US$) of Lebanon?
Your answer should be very brief. 2.99e+08. In the year 2005, what is the difference between the Aid flow from UN agencies (US$) in Upper middle income and Aid flow from UN agencies (US$) in Lebanon?
Your answer should be very brief. 9.22e+07. In the year 2006, what is the difference between the Aid flow from UN agencies (US$) of Arab World and Aid flow from UN agencies (US$) of Upper middle income?
Your answer should be compact. 2.29e+08. In the year 2006, what is the difference between the Aid flow from UN agencies (US$) in Arab World and Aid flow from UN agencies (US$) in Lebanon?
Your response must be concise. 3.20e+08. In the year 2006, what is the difference between the Aid flow from UN agencies (US$) in Middle income and Aid flow from UN agencies (US$) in Upper middle income?
Provide a short and direct response. 2.29e+08. In the year 2006, what is the difference between the Aid flow from UN agencies (US$) of Middle income and Aid flow from UN agencies (US$) of Lebanon?
Offer a terse response. 3.20e+08. In the year 2006, what is the difference between the Aid flow from UN agencies (US$) of Upper middle income and Aid flow from UN agencies (US$) of Lebanon?
Ensure brevity in your answer.  9.16e+07. In the year 2007, what is the difference between the Aid flow from UN agencies (US$) in Arab World and Aid flow from UN agencies (US$) in Middle income?
Keep it short and to the point. 0. In the year 2007, what is the difference between the Aid flow from UN agencies (US$) in Arab World and Aid flow from UN agencies (US$) in Upper middle income?
Your answer should be compact. 2.38e+08. In the year 2007, what is the difference between the Aid flow from UN agencies (US$) of Arab World and Aid flow from UN agencies (US$) of Lebanon?
Your answer should be compact. 3.37e+08. In the year 2007, what is the difference between the Aid flow from UN agencies (US$) in Middle income and Aid flow from UN agencies (US$) in Upper middle income?
Offer a terse response. 2.38e+08. In the year 2007, what is the difference between the Aid flow from UN agencies (US$) in Middle income and Aid flow from UN agencies (US$) in Lebanon?
Ensure brevity in your answer.  3.37e+08. In the year 2007, what is the difference between the Aid flow from UN agencies (US$) of Upper middle income and Aid flow from UN agencies (US$) of Lebanon?
Give a very brief answer. 9.89e+07. In the year 2008, what is the difference between the Aid flow from UN agencies (US$) of Arab World and Aid flow from UN agencies (US$) of Middle income?
Give a very brief answer. 0. In the year 2008, what is the difference between the Aid flow from UN agencies (US$) of Arab World and Aid flow from UN agencies (US$) of Upper middle income?
Offer a very short reply. 2.97e+08. In the year 2008, what is the difference between the Aid flow from UN agencies (US$) in Arab World and Aid flow from UN agencies (US$) in Lebanon?
Offer a terse response. 4.12e+08. In the year 2008, what is the difference between the Aid flow from UN agencies (US$) of Middle income and Aid flow from UN agencies (US$) of Upper middle income?
Offer a terse response. 2.97e+08. In the year 2008, what is the difference between the Aid flow from UN agencies (US$) in Middle income and Aid flow from UN agencies (US$) in Lebanon?
Offer a terse response. 4.12e+08. In the year 2008, what is the difference between the Aid flow from UN agencies (US$) in Upper middle income and Aid flow from UN agencies (US$) in Lebanon?
Your answer should be compact. 1.15e+08. In the year 2009, what is the difference between the Aid flow from UN agencies (US$) in Arab World and Aid flow from UN agencies (US$) in Upper middle income?
Keep it short and to the point. 2.88e+08. In the year 2009, what is the difference between the Aid flow from UN agencies (US$) in Arab World and Aid flow from UN agencies (US$) in Lebanon?
Your answer should be compact. 4.06e+08. In the year 2009, what is the difference between the Aid flow from UN agencies (US$) in Middle income and Aid flow from UN agencies (US$) in Upper middle income?
Offer a terse response. 2.88e+08. In the year 2009, what is the difference between the Aid flow from UN agencies (US$) in Middle income and Aid flow from UN agencies (US$) in Lebanon?
Provide a short and direct response. 4.06e+08. In the year 2009, what is the difference between the Aid flow from UN agencies (US$) in Upper middle income and Aid flow from UN agencies (US$) in Lebanon?
Offer a very short reply. 1.18e+08. In the year 2010, what is the difference between the Aid flow from UN agencies (US$) in Arab World and Aid flow from UN agencies (US$) in Middle income?
Your answer should be very brief. 0. In the year 2010, what is the difference between the Aid flow from UN agencies (US$) of Arab World and Aid flow from UN agencies (US$) of Upper middle income?
Your answer should be compact. 3.41e+08. In the year 2010, what is the difference between the Aid flow from UN agencies (US$) of Arab World and Aid flow from UN agencies (US$) of Lebanon?
Your response must be concise. 4.74e+08. In the year 2010, what is the difference between the Aid flow from UN agencies (US$) in Middle income and Aid flow from UN agencies (US$) in Upper middle income?
Ensure brevity in your answer.  3.41e+08. In the year 2010, what is the difference between the Aid flow from UN agencies (US$) of Middle income and Aid flow from UN agencies (US$) of Lebanon?
Your answer should be compact. 4.74e+08. In the year 2010, what is the difference between the Aid flow from UN agencies (US$) in Upper middle income and Aid flow from UN agencies (US$) in Lebanon?
Provide a short and direct response. 1.33e+08. What is the ratio of the Aid flow from UN agencies (US$) in Middle income in 2003 to that in 2004?
Your answer should be compact. 0.96. What is the ratio of the Aid flow from UN agencies (US$) in Upper middle income in 2003 to that in 2004?
Your answer should be compact. 0.95. What is the ratio of the Aid flow from UN agencies (US$) in Lebanon in 2003 to that in 2004?
Ensure brevity in your answer.  0.89. What is the ratio of the Aid flow from UN agencies (US$) of Arab World in 2003 to that in 2005?
Your response must be concise. 1.23. What is the ratio of the Aid flow from UN agencies (US$) in Middle income in 2003 to that in 2005?
Ensure brevity in your answer.  1.23. What is the ratio of the Aid flow from UN agencies (US$) in Upper middle income in 2003 to that in 2005?
Provide a succinct answer. 0.97. What is the ratio of the Aid flow from UN agencies (US$) in Arab World in 2003 to that in 2006?
Keep it short and to the point. 1.16. What is the ratio of the Aid flow from UN agencies (US$) in Middle income in 2003 to that in 2006?
Make the answer very short. 1.16. What is the ratio of the Aid flow from UN agencies (US$) in Upper middle income in 2003 to that in 2006?
Your response must be concise. 0.98. What is the ratio of the Aid flow from UN agencies (US$) in Lebanon in 2003 to that in 2006?
Make the answer very short. 1. What is the ratio of the Aid flow from UN agencies (US$) in Arab World in 2003 to that in 2007?
Your response must be concise. 1.11. What is the ratio of the Aid flow from UN agencies (US$) in Middle income in 2003 to that in 2007?
Make the answer very short. 1.11. What is the ratio of the Aid flow from UN agencies (US$) of Upper middle income in 2003 to that in 2007?
Give a very brief answer. 0.93. What is the ratio of the Aid flow from UN agencies (US$) in Arab World in 2003 to that in 2008?
Make the answer very short. 0.91. What is the ratio of the Aid flow from UN agencies (US$) in Middle income in 2003 to that in 2008?
Offer a terse response. 0.91. What is the ratio of the Aid flow from UN agencies (US$) in Upper middle income in 2003 to that in 2008?
Ensure brevity in your answer.  0.79. What is the ratio of the Aid flow from UN agencies (US$) of Lebanon in 2003 to that in 2008?
Provide a succinct answer. 0.84. What is the ratio of the Aid flow from UN agencies (US$) of Arab World in 2003 to that in 2009?
Keep it short and to the point. 0.91. What is the ratio of the Aid flow from UN agencies (US$) of Middle income in 2003 to that in 2009?
Your answer should be compact. 0.91. What is the ratio of the Aid flow from UN agencies (US$) in Upper middle income in 2003 to that in 2009?
Your answer should be compact. 0.76. What is the ratio of the Aid flow from UN agencies (US$) in Lebanon in 2003 to that in 2009?
Ensure brevity in your answer.  0.76. What is the ratio of the Aid flow from UN agencies (US$) in Arab World in 2003 to that in 2010?
Keep it short and to the point. 0.79. What is the ratio of the Aid flow from UN agencies (US$) in Middle income in 2003 to that in 2010?
Ensure brevity in your answer.  0.79. What is the ratio of the Aid flow from UN agencies (US$) of Upper middle income in 2003 to that in 2010?
Make the answer very short. 0.69. What is the ratio of the Aid flow from UN agencies (US$) in Lebanon in 2003 to that in 2010?
Provide a short and direct response. 0.72. What is the ratio of the Aid flow from UN agencies (US$) in Arab World in 2004 to that in 2005?
Your answer should be very brief. 1.28. What is the ratio of the Aid flow from UN agencies (US$) in Middle income in 2004 to that in 2005?
Your answer should be compact. 1.28. What is the ratio of the Aid flow from UN agencies (US$) of Upper middle income in 2004 to that in 2005?
Offer a terse response. 1.02. What is the ratio of the Aid flow from UN agencies (US$) of Lebanon in 2004 to that in 2005?
Your response must be concise. 1.12. What is the ratio of the Aid flow from UN agencies (US$) of Arab World in 2004 to that in 2006?
Offer a terse response. 1.21. What is the ratio of the Aid flow from UN agencies (US$) of Middle income in 2004 to that in 2006?
Offer a terse response. 1.21. What is the ratio of the Aid flow from UN agencies (US$) in Upper middle income in 2004 to that in 2006?
Make the answer very short. 1.03. What is the ratio of the Aid flow from UN agencies (US$) in Lebanon in 2004 to that in 2006?
Offer a very short reply. 1.12. What is the ratio of the Aid flow from UN agencies (US$) of Arab World in 2004 to that in 2007?
Offer a terse response. 1.16. What is the ratio of the Aid flow from UN agencies (US$) in Middle income in 2004 to that in 2007?
Make the answer very short. 1.16. What is the ratio of the Aid flow from UN agencies (US$) in Upper middle income in 2004 to that in 2007?
Your answer should be very brief. 0.98. What is the ratio of the Aid flow from UN agencies (US$) of Lebanon in 2004 to that in 2007?
Offer a terse response. 1.11. What is the ratio of the Aid flow from UN agencies (US$) of Arab World in 2004 to that in 2008?
Provide a short and direct response. 0.95. What is the ratio of the Aid flow from UN agencies (US$) of Middle income in 2004 to that in 2008?
Your response must be concise. 0.95. What is the ratio of the Aid flow from UN agencies (US$) in Upper middle income in 2004 to that in 2008?
Your answer should be compact. 0.83. What is the ratio of the Aid flow from UN agencies (US$) in Lebanon in 2004 to that in 2008?
Offer a terse response. 0.94. What is the ratio of the Aid flow from UN agencies (US$) of Arab World in 2004 to that in 2009?
Give a very brief answer. 0.95. What is the ratio of the Aid flow from UN agencies (US$) of Middle income in 2004 to that in 2009?
Your response must be concise. 0.95. What is the ratio of the Aid flow from UN agencies (US$) in Upper middle income in 2004 to that in 2009?
Your answer should be very brief. 0.79. What is the ratio of the Aid flow from UN agencies (US$) of Lebanon in 2004 to that in 2009?
Your answer should be very brief. 0.86. What is the ratio of the Aid flow from UN agencies (US$) of Arab World in 2004 to that in 2010?
Give a very brief answer. 0.82. What is the ratio of the Aid flow from UN agencies (US$) of Middle income in 2004 to that in 2010?
Offer a terse response. 0.82. What is the ratio of the Aid flow from UN agencies (US$) in Upper middle income in 2004 to that in 2010?
Offer a terse response. 0.72. What is the ratio of the Aid flow from UN agencies (US$) in Lebanon in 2004 to that in 2010?
Make the answer very short. 0.81. What is the ratio of the Aid flow from UN agencies (US$) in Arab World in 2005 to that in 2006?
Provide a succinct answer. 0.94. What is the ratio of the Aid flow from UN agencies (US$) of Middle income in 2005 to that in 2006?
Ensure brevity in your answer.  0.94. What is the ratio of the Aid flow from UN agencies (US$) in Lebanon in 2005 to that in 2006?
Offer a terse response. 1. What is the ratio of the Aid flow from UN agencies (US$) of Arab World in 2005 to that in 2007?
Give a very brief answer. 0.9. What is the ratio of the Aid flow from UN agencies (US$) of Middle income in 2005 to that in 2007?
Give a very brief answer. 0.9. What is the ratio of the Aid flow from UN agencies (US$) in Upper middle income in 2005 to that in 2007?
Give a very brief answer. 0.95. What is the ratio of the Aid flow from UN agencies (US$) of Lebanon in 2005 to that in 2007?
Give a very brief answer. 0.99. What is the ratio of the Aid flow from UN agencies (US$) of Arab World in 2005 to that in 2008?
Make the answer very short. 0.74. What is the ratio of the Aid flow from UN agencies (US$) of Middle income in 2005 to that in 2008?
Make the answer very short. 0.74. What is the ratio of the Aid flow from UN agencies (US$) in Upper middle income in 2005 to that in 2008?
Your answer should be compact. 0.81. What is the ratio of the Aid flow from UN agencies (US$) of Lebanon in 2005 to that in 2008?
Provide a short and direct response. 0.84. What is the ratio of the Aid flow from UN agencies (US$) in Arab World in 2005 to that in 2009?
Offer a very short reply. 0.74. What is the ratio of the Aid flow from UN agencies (US$) in Middle income in 2005 to that in 2009?
Your answer should be compact. 0.74. What is the ratio of the Aid flow from UN agencies (US$) of Upper middle income in 2005 to that in 2009?
Ensure brevity in your answer.  0.78. What is the ratio of the Aid flow from UN agencies (US$) of Lebanon in 2005 to that in 2009?
Your answer should be compact. 0.77. What is the ratio of the Aid flow from UN agencies (US$) of Arab World in 2005 to that in 2010?
Your answer should be compact. 0.64. What is the ratio of the Aid flow from UN agencies (US$) in Middle income in 2005 to that in 2010?
Your response must be concise. 0.64. What is the ratio of the Aid flow from UN agencies (US$) of Upper middle income in 2005 to that in 2010?
Provide a succinct answer. 0.7. What is the ratio of the Aid flow from UN agencies (US$) in Lebanon in 2005 to that in 2010?
Make the answer very short. 0.72. What is the ratio of the Aid flow from UN agencies (US$) in Arab World in 2006 to that in 2007?
Your answer should be very brief. 0.96. What is the ratio of the Aid flow from UN agencies (US$) of Middle income in 2006 to that in 2007?
Give a very brief answer. 0.96. What is the ratio of the Aid flow from UN agencies (US$) of Upper middle income in 2006 to that in 2007?
Keep it short and to the point. 0.95. What is the ratio of the Aid flow from UN agencies (US$) in Lebanon in 2006 to that in 2007?
Give a very brief answer. 0.99. What is the ratio of the Aid flow from UN agencies (US$) of Arab World in 2006 to that in 2008?
Your answer should be very brief. 0.79. What is the ratio of the Aid flow from UN agencies (US$) in Middle income in 2006 to that in 2008?
Provide a short and direct response. 0.79. What is the ratio of the Aid flow from UN agencies (US$) of Upper middle income in 2006 to that in 2008?
Offer a very short reply. 0.81. What is the ratio of the Aid flow from UN agencies (US$) of Lebanon in 2006 to that in 2008?
Give a very brief answer. 0.84. What is the ratio of the Aid flow from UN agencies (US$) of Arab World in 2006 to that in 2009?
Your response must be concise. 0.79. What is the ratio of the Aid flow from UN agencies (US$) of Middle income in 2006 to that in 2009?
Your answer should be compact. 0.79. What is the ratio of the Aid flow from UN agencies (US$) in Upper middle income in 2006 to that in 2009?
Keep it short and to the point. 0.77. What is the ratio of the Aid flow from UN agencies (US$) of Lebanon in 2006 to that in 2009?
Keep it short and to the point. 0.77. What is the ratio of the Aid flow from UN agencies (US$) of Arab World in 2006 to that in 2010?
Offer a terse response. 0.68. What is the ratio of the Aid flow from UN agencies (US$) of Middle income in 2006 to that in 2010?
Provide a succinct answer. 0.68. What is the ratio of the Aid flow from UN agencies (US$) in Upper middle income in 2006 to that in 2010?
Your response must be concise. 0.7. What is the ratio of the Aid flow from UN agencies (US$) in Lebanon in 2006 to that in 2010?
Make the answer very short. 0.72. What is the ratio of the Aid flow from UN agencies (US$) in Arab World in 2007 to that in 2008?
Give a very brief answer. 0.82. What is the ratio of the Aid flow from UN agencies (US$) in Middle income in 2007 to that in 2008?
Make the answer very short. 0.82. What is the ratio of the Aid flow from UN agencies (US$) of Upper middle income in 2007 to that in 2008?
Ensure brevity in your answer.  0.86. What is the ratio of the Aid flow from UN agencies (US$) in Lebanon in 2007 to that in 2008?
Keep it short and to the point. 0.85. What is the ratio of the Aid flow from UN agencies (US$) in Arab World in 2007 to that in 2009?
Your response must be concise. 0.82. What is the ratio of the Aid flow from UN agencies (US$) of Middle income in 2007 to that in 2009?
Offer a very short reply. 0.82. What is the ratio of the Aid flow from UN agencies (US$) of Upper middle income in 2007 to that in 2009?
Offer a terse response. 0.82. What is the ratio of the Aid flow from UN agencies (US$) of Lebanon in 2007 to that in 2009?
Your answer should be very brief. 0.77. What is the ratio of the Aid flow from UN agencies (US$) of Arab World in 2007 to that in 2010?
Keep it short and to the point. 0.71. What is the ratio of the Aid flow from UN agencies (US$) of Middle income in 2007 to that in 2010?
Give a very brief answer. 0.71. What is the ratio of the Aid flow from UN agencies (US$) in Upper middle income in 2007 to that in 2010?
Provide a succinct answer. 0.74. What is the ratio of the Aid flow from UN agencies (US$) in Lebanon in 2007 to that in 2010?
Provide a short and direct response. 0.73. What is the ratio of the Aid flow from UN agencies (US$) of Arab World in 2008 to that in 2009?
Make the answer very short. 1. What is the ratio of the Aid flow from UN agencies (US$) of Upper middle income in 2008 to that in 2009?
Offer a terse response. 0.95. What is the ratio of the Aid flow from UN agencies (US$) in Lebanon in 2008 to that in 2009?
Provide a succinct answer. 0.91. What is the ratio of the Aid flow from UN agencies (US$) in Arab World in 2008 to that in 2010?
Your answer should be compact. 0.87. What is the ratio of the Aid flow from UN agencies (US$) of Middle income in 2008 to that in 2010?
Offer a very short reply. 0.87. What is the ratio of the Aid flow from UN agencies (US$) of Upper middle income in 2008 to that in 2010?
Offer a terse response. 0.86. What is the ratio of the Aid flow from UN agencies (US$) in Lebanon in 2008 to that in 2010?
Give a very brief answer. 0.86. What is the ratio of the Aid flow from UN agencies (US$) of Arab World in 2009 to that in 2010?
Provide a succinct answer. 0.87. What is the ratio of the Aid flow from UN agencies (US$) in Middle income in 2009 to that in 2010?
Provide a succinct answer. 0.87. What is the ratio of the Aid flow from UN agencies (US$) of Upper middle income in 2009 to that in 2010?
Your answer should be compact. 0.91. What is the ratio of the Aid flow from UN agencies (US$) of Lebanon in 2009 to that in 2010?
Your response must be concise. 0.94. What is the difference between the highest and the second highest Aid flow from UN agencies (US$) of Arab World?
Give a very brief answer. 7.18e+07. What is the difference between the highest and the second highest Aid flow from UN agencies (US$) of Middle income?
Your answer should be compact. 7.18e+07. What is the difference between the highest and the second highest Aid flow from UN agencies (US$) of Upper middle income?
Offer a very short reply. 1.89e+07. What is the difference between the highest and the second highest Aid flow from UN agencies (US$) of Lebanon?
Your answer should be compact. 3.99e+06. What is the difference between the highest and the lowest Aid flow from UN agencies (US$) in Arab World?
Make the answer very short. 1.95e+08. What is the difference between the highest and the lowest Aid flow from UN agencies (US$) of Middle income?
Provide a short and direct response. 1.95e+08. What is the difference between the highest and the lowest Aid flow from UN agencies (US$) of Upper middle income?
Offer a terse response. 6.41e+07. What is the difference between the highest and the lowest Aid flow from UN agencies (US$) of Lebanon?
Your answer should be compact. 1.99e+07. 